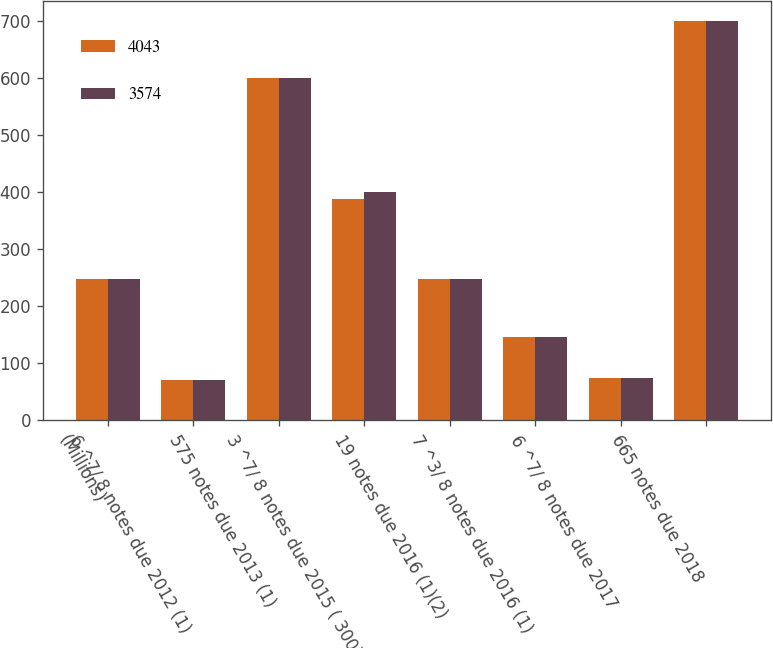Convert chart. <chart><loc_0><loc_0><loc_500><loc_500><stacked_bar_chart><ecel><fcel>(Millions)<fcel>6 ^7/ 8 notes due 2012 (1)<fcel>575 notes due 2013 (1)<fcel>3 ^7/ 8 notes due 2015 ( 300)<fcel>19 notes due 2016 (1)(2)<fcel>7 ^3/ 8 notes due 2016 (1)<fcel>6 ^7/ 8 notes due 2017<fcel>665 notes due 2018<nl><fcel>4043<fcel>248<fcel>71<fcel>600<fcel>388<fcel>248<fcel>146<fcel>74<fcel>700<nl><fcel>3574<fcel>248<fcel>71<fcel>600<fcel>401<fcel>248<fcel>146<fcel>74<fcel>700<nl></chart> 